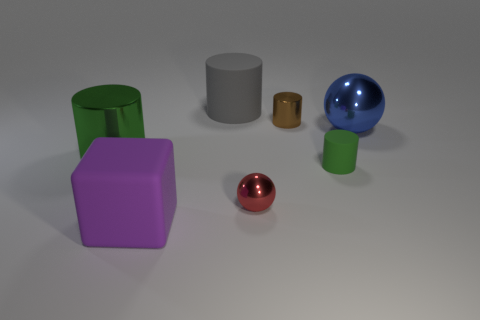Subtract all gray balls. How many green cylinders are left? 2 Subtract all gray cylinders. How many cylinders are left? 3 Add 3 gray cylinders. How many objects exist? 10 Subtract all blue cylinders. Subtract all red cubes. How many cylinders are left? 4 Subtract all cubes. How many objects are left? 6 Subtract all big metal cylinders. Subtract all tiny matte things. How many objects are left? 5 Add 6 big purple objects. How many big purple objects are left? 7 Add 3 cubes. How many cubes exist? 4 Subtract 0 gray blocks. How many objects are left? 7 